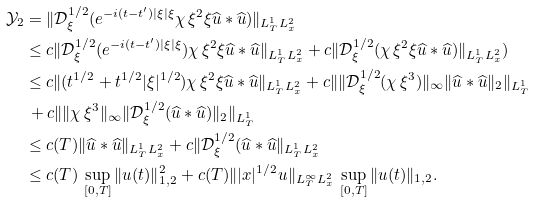<formula> <loc_0><loc_0><loc_500><loc_500>\mathcal { Y } _ { 2 } & = \| \mathcal { D } _ { \xi } ^ { 1 / 2 } ( e ^ { - i ( t - t ^ { \prime } ) | \xi | \xi } \chi \, \xi ^ { 2 } \xi \widehat { u } \ast \widehat { u } ) \| _ { L ^ { 1 } _ { T } L ^ { 2 } _ { x } } \\ & \leq c \| \mathcal { D } _ { \xi } ^ { 1 / 2 } ( e ^ { - i ( t - t ^ { \prime } ) | \xi | \xi } ) \chi \, \xi ^ { 2 } \xi \widehat { u } \ast \widehat { u } \| _ { L ^ { 1 } _ { T } L ^ { 2 } _ { x } } + c \| \mathcal { D } _ { \xi } ^ { 1 / 2 } ( \chi \, \xi ^ { 2 } \xi \widehat { u } \ast \widehat { u } ) \| _ { L ^ { 1 } _ { T } L ^ { 2 } _ { x } } ) \\ & \leq c \| ( t ^ { 1 / 2 } + t ^ { 1 / 2 } | \xi | ^ { 1 / 2 } ) \chi \, \xi ^ { 2 } \xi \widehat { u } \ast \widehat { u } \| _ { L ^ { 1 } _ { T } L ^ { 2 } _ { x } } + c \| \| \mathcal { D } _ { \xi } ^ { 1 / 2 } ( \chi \, \xi ^ { 3 } ) \| _ { \infty } \| \widehat { u } \ast \widehat { u } \| _ { 2 } \| _ { L ^ { 1 } _ { T } } \\ & \, + c \| \| \chi \, \xi ^ { 3 } \| _ { \infty } \| \mathcal { D } _ { \xi } ^ { 1 / 2 } ( \widehat { u } \ast \widehat { u } ) \| _ { 2 } \| _ { L ^ { 1 } _ { T } } \\ & \leq c ( T ) \| \widehat { u } \ast \widehat { u } \| _ { L ^ { 1 } _ { T } L ^ { 2 } _ { x } } + c \| \mathcal { D } _ { \xi } ^ { 1 / 2 } ( \widehat { u } \ast \widehat { u } \| _ { L ^ { 1 } _ { T } L ^ { 2 } _ { x } } \\ & \leq c ( T ) \, \sup _ { [ 0 , T ] } \| u ( t ) \| ^ { 2 } _ { 1 , 2 } + c ( T ) \| | x | ^ { 1 / 2 } u \| _ { L ^ { \infty } _ { T } L ^ { 2 } _ { x } } \, \sup _ { [ 0 , T ] } \| u ( t ) \| _ { 1 , 2 } .</formula> 